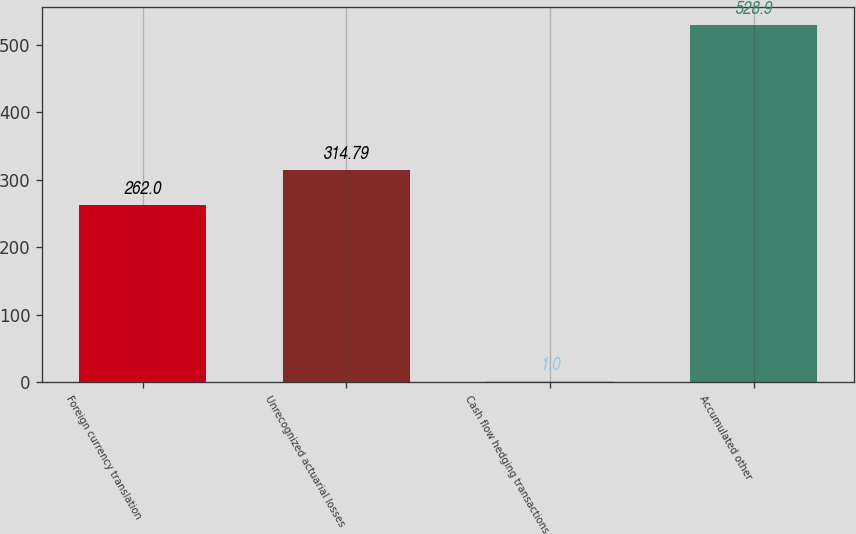Convert chart. <chart><loc_0><loc_0><loc_500><loc_500><bar_chart><fcel>Foreign currency translation<fcel>Unrecognized actuarial losses<fcel>Cash flow hedging transactions<fcel>Accumulated other<nl><fcel>262<fcel>314.79<fcel>1<fcel>528.9<nl></chart> 